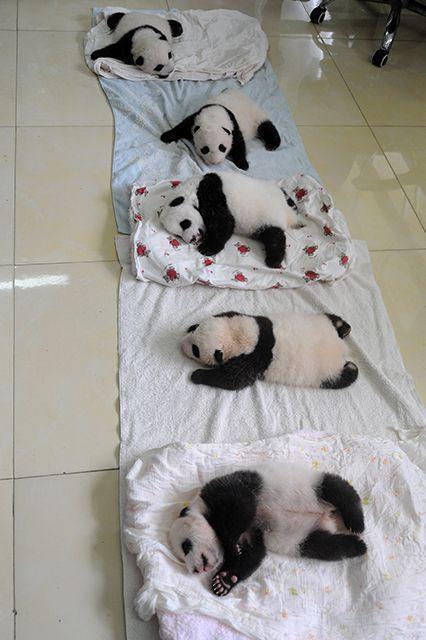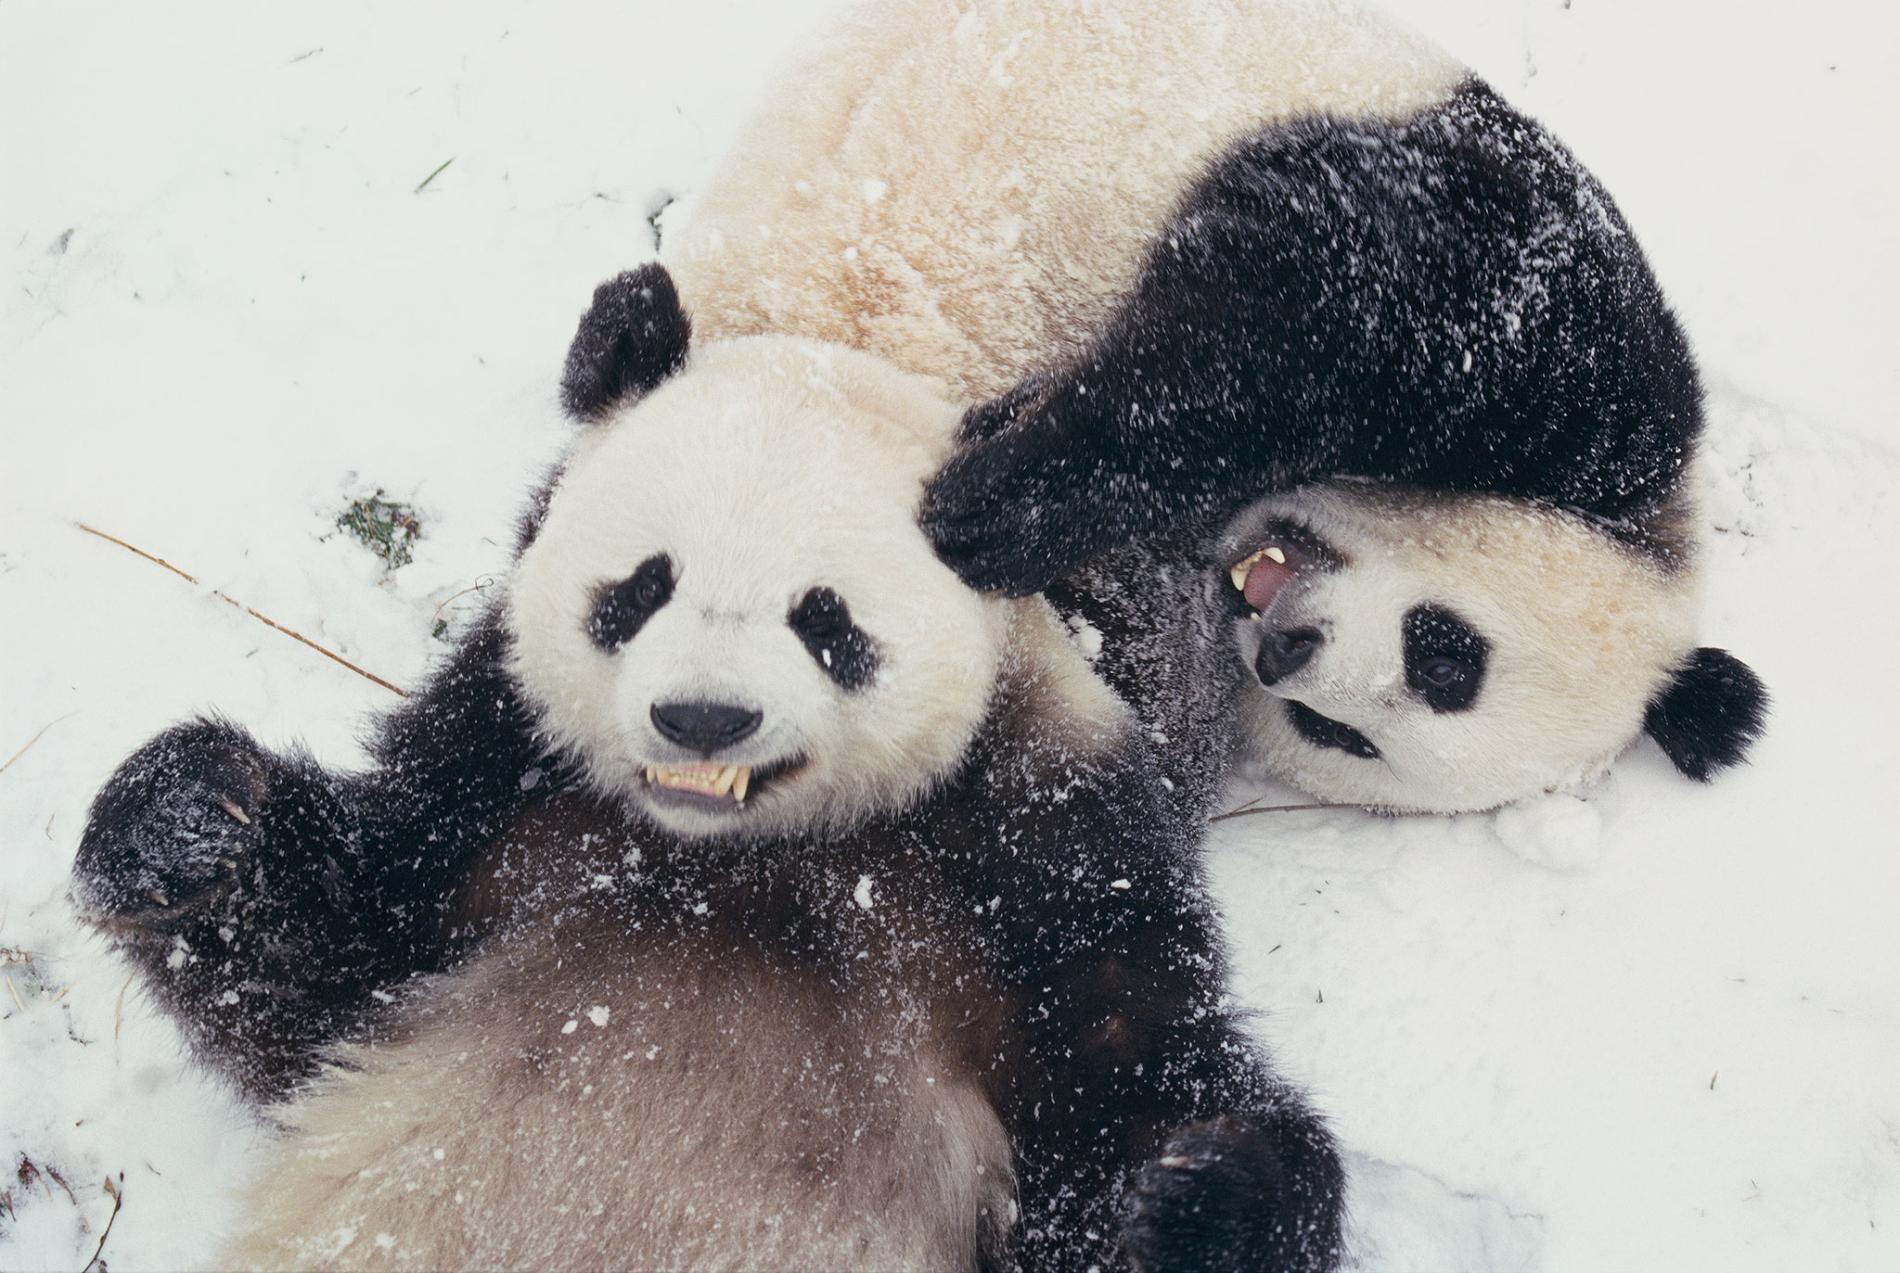The first image is the image on the left, the second image is the image on the right. Analyze the images presented: Is the assertion "At least one image shows many pandas on a white blanket surrounded by wooden rails, like a crib." valid? Answer yes or no. No. The first image is the image on the left, the second image is the image on the right. Evaluate the accuracy of this statement regarding the images: "Exactly two pandas are playing in the snow in one of the images.". Is it true? Answer yes or no. Yes. 